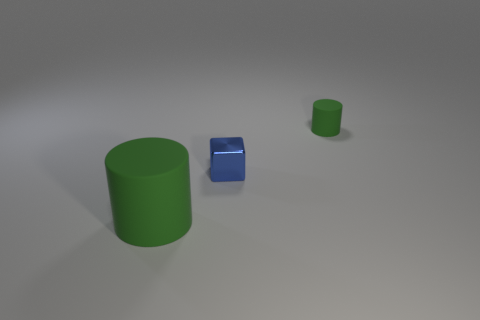Can you describe the lighting in the scene? The scene is illuminated by a soft, diffuse light source that casts gentle shadows to the right of the objects. The lack of harsh shadows or bright highlights suggests an ambient or indirect lighting setup, which gives the scene a calm and even tone. 